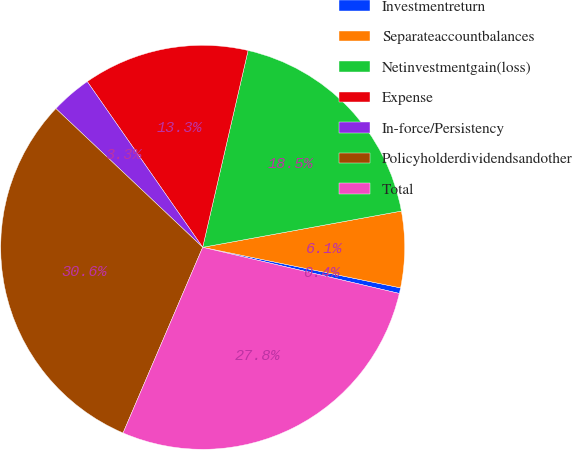Convert chart to OTSL. <chart><loc_0><loc_0><loc_500><loc_500><pie_chart><fcel>Investmentreturn<fcel>Separateaccountbalances<fcel>Netinvestmentgain(loss)<fcel>Expense<fcel>In-force/Persistency<fcel>Policyholderdividendsandother<fcel>Total<nl><fcel>0.45%<fcel>6.09%<fcel>18.52%<fcel>13.29%<fcel>3.27%<fcel>30.6%<fcel>27.78%<nl></chart> 